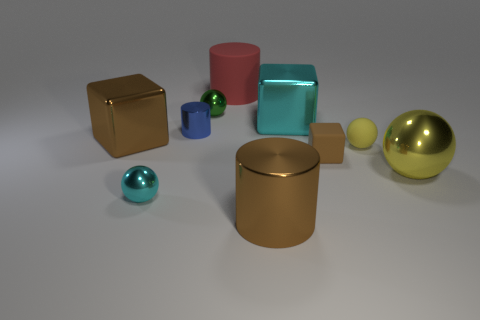What size is the green object that is the same shape as the big yellow object?
Offer a terse response. Small. There is a large cyan object behind the yellow rubber ball; what number of yellow matte things are on the right side of it?
Provide a succinct answer. 1. There is a cube that is both right of the tiny cyan metallic object and behind the yellow rubber object; what is its size?
Your answer should be very brief. Large. Is the material of the big yellow ball the same as the cylinder that is behind the blue metallic thing?
Provide a succinct answer. No. Is the number of small cylinders on the right side of the cyan shiny block less than the number of big metal blocks to the left of the big brown cylinder?
Offer a terse response. Yes. There is a ball that is on the right side of the tiny yellow matte ball; what is it made of?
Keep it short and to the point. Metal. The metallic ball that is both to the left of the tiny matte ball and in front of the green thing is what color?
Make the answer very short. Cyan. How many other objects are there of the same color as the tiny metal cylinder?
Ensure brevity in your answer.  0. What color is the cylinder that is behind the blue object?
Make the answer very short. Red. Are there any green metal spheres that have the same size as the matte cube?
Provide a short and direct response. Yes. 